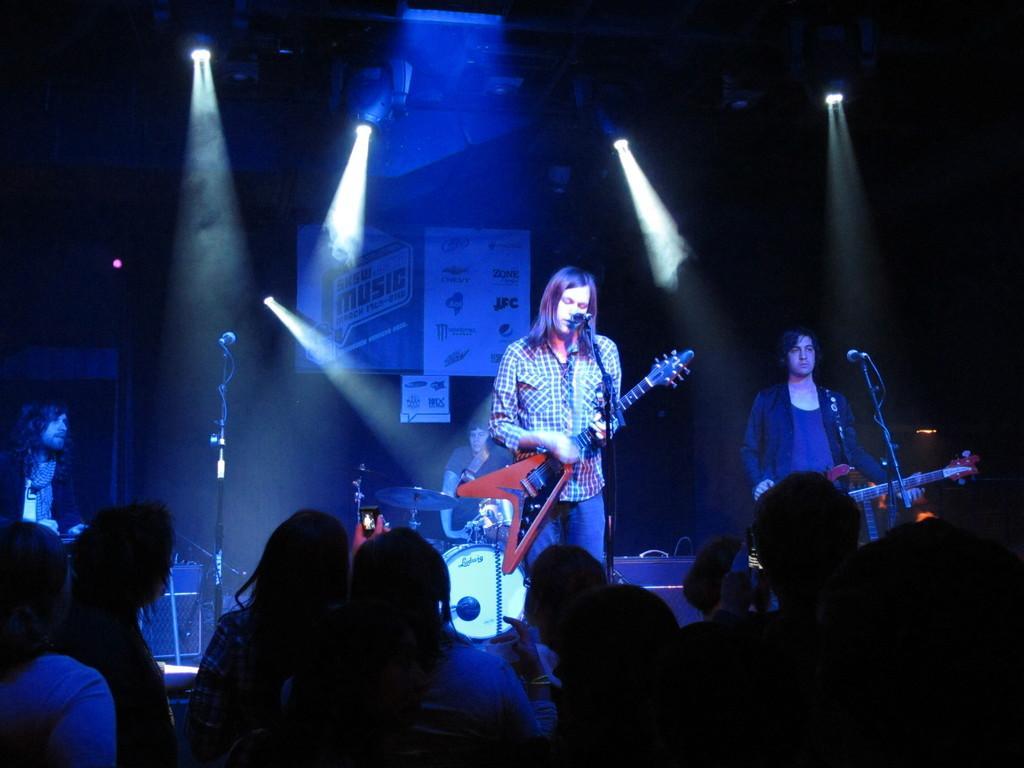Can you describe this image briefly? In this picture there is a band performing on the stage. In the foreground there are audience. At the center of the picture there are microphones, drums, cables and people playing guitar. In the background there are lights and a board. 